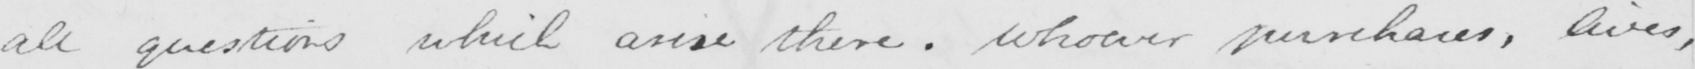Can you read and transcribe this handwriting? all questions which arise there . Whoever purchases , lives , 